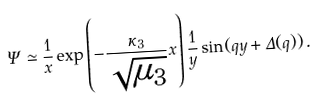<formula> <loc_0><loc_0><loc_500><loc_500>\Psi \simeq \frac { 1 } { x } \exp \left ( - \frac { \kappa _ { 3 } } { \sqrt { \mu _ { 3 } } } x \right ) \frac { 1 } { y } \sin ( q y + \Delta ( q ) ) \, .</formula> 